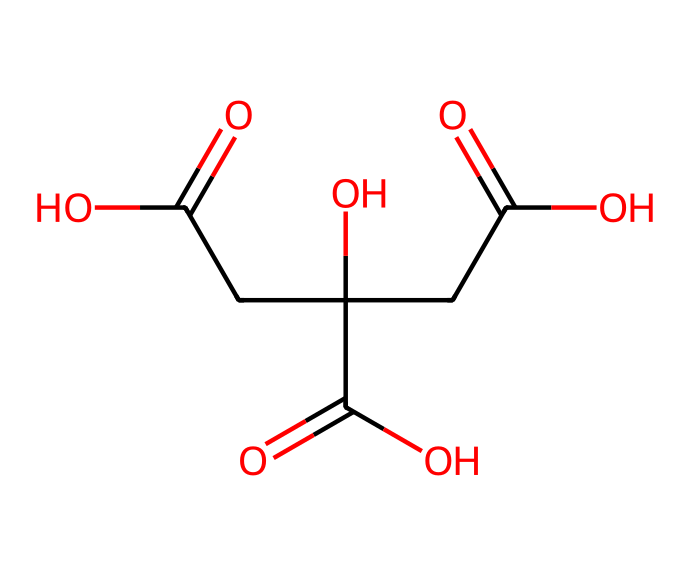What is the name of this chemical? The SMILES representation given translates to citric acid, which is commonly known for its role in both culinary and preservation contexts.
Answer: citric acid How many carboxylic acid groups are present in this chemical? The structure of citric acid includes three carboxylic acid functional groups, each denoted by -COOH. This is identified from the structure by locating the carbon atoms bonded to two oxygens (O) where one oxygen is also bonded to a hydrogen (H).
Answer: three What is the role of citric acid in preserving library books? Citric acid serves as a chelating agent, meaning it binds to metal ions that might catalyze the degradation of paper over time. Its acidic property can help inhibit mold growth, contributing to the preservation of books.
Answer: chelating agent What is the pH level of citric acid when dissolved in water? Citric acid is a weak acid with a typical pH level around 3 when dissolved in water, indicating its acidity but also reflecting its relatively mild nature.
Answer: 3 Which elements are found in citric acid? Citric acid is composed of carbon (C), hydrogen (H), and oxygen (O). By analyzing the SMILES representation, one can count the atoms of each element based on their notations and structure.
Answer: carbon, hydrogen, oxygen What type of acid is citric acid classified as? Citric acid is classified as a weak organic acid due to its ability to partially dissociate in solution, which is supported by its structure and the presence of multiple carboxyl groups.
Answer: weak organic acid 